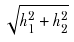Convert formula to latex. <formula><loc_0><loc_0><loc_500><loc_500>\sqrt { h _ { 1 } ^ { 2 } + h _ { 2 } ^ { 2 } }</formula> 